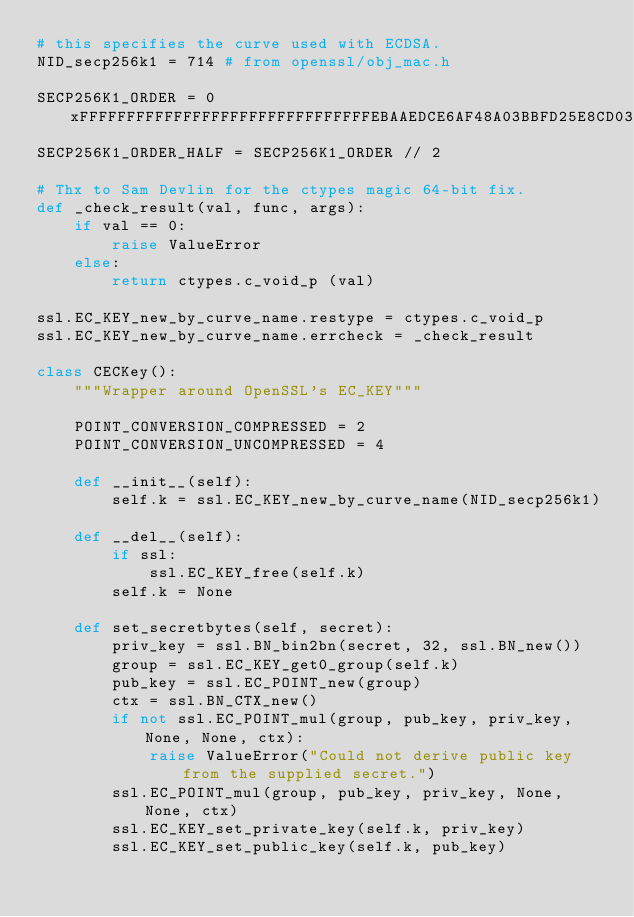<code> <loc_0><loc_0><loc_500><loc_500><_Python_># this specifies the curve used with ECDSA.
NID_secp256k1 = 714 # from openssl/obj_mac.h

SECP256K1_ORDER = 0xFFFFFFFFFFFFFFFFFFFFFFFFFFFFFFFEBAAEDCE6AF48A03BBFD25E8CD0364141
SECP256K1_ORDER_HALF = SECP256K1_ORDER // 2

# Thx to Sam Devlin for the ctypes magic 64-bit fix.
def _check_result(val, func, args):
    if val == 0:
        raise ValueError
    else:
        return ctypes.c_void_p (val)

ssl.EC_KEY_new_by_curve_name.restype = ctypes.c_void_p
ssl.EC_KEY_new_by_curve_name.errcheck = _check_result

class CECKey():
    """Wrapper around OpenSSL's EC_KEY"""

    POINT_CONVERSION_COMPRESSED = 2
    POINT_CONVERSION_UNCOMPRESSED = 4

    def __init__(self):
        self.k = ssl.EC_KEY_new_by_curve_name(NID_secp256k1)

    def __del__(self):
        if ssl:
            ssl.EC_KEY_free(self.k)
        self.k = None

    def set_secretbytes(self, secret):
        priv_key = ssl.BN_bin2bn(secret, 32, ssl.BN_new())
        group = ssl.EC_KEY_get0_group(self.k)
        pub_key = ssl.EC_POINT_new(group)
        ctx = ssl.BN_CTX_new()
        if not ssl.EC_POINT_mul(group, pub_key, priv_key, None, None, ctx):
            raise ValueError("Could not derive public key from the supplied secret.")
        ssl.EC_POINT_mul(group, pub_key, priv_key, None, None, ctx)
        ssl.EC_KEY_set_private_key(self.k, priv_key)
        ssl.EC_KEY_set_public_key(self.k, pub_key)</code> 